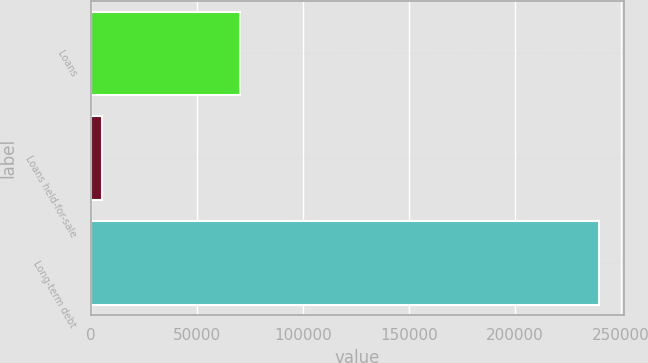Convert chart. <chart><loc_0><loc_0><loc_500><loc_500><bar_chart><fcel>Loans<fcel>Loans held-for-sale<fcel>Long-term debt<nl><fcel>70223<fcel>5347<fcel>239596<nl></chart> 